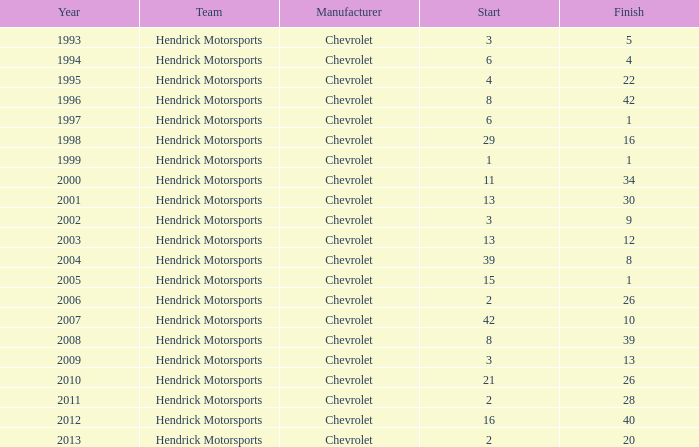Which squad started with 8 years earlier than 2008? Hendrick Motorsports. 